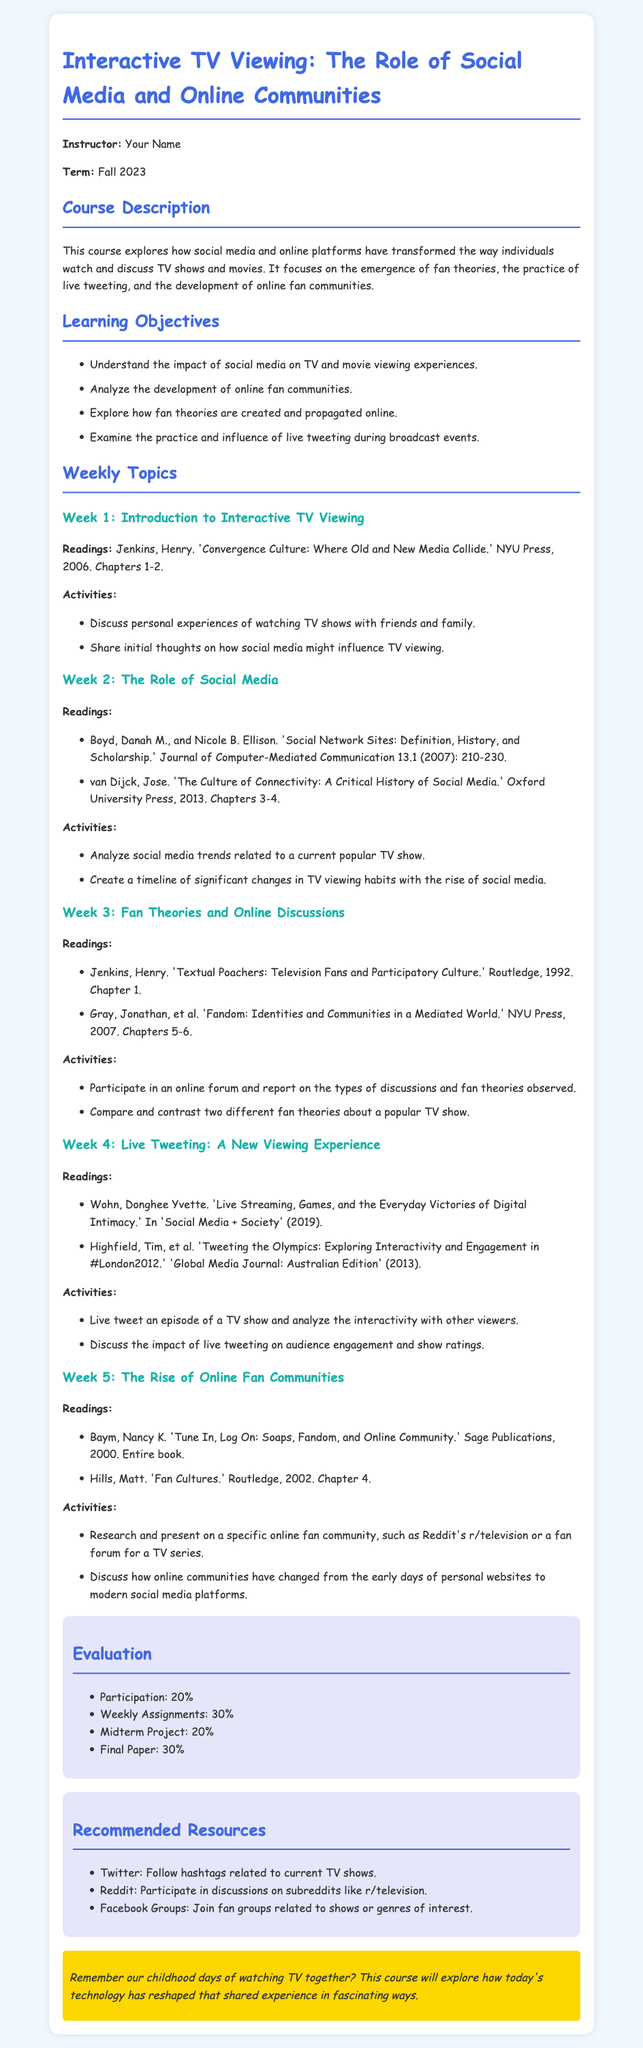What is the course title? The course title is stated at the beginning of the document.
Answer: Interactive TV Viewing: The Role of Social Media and Online Communities Who is the instructor? The instructor's name is listed in the introductory section of the document.
Answer: Your Name What percentage of the evaluation is based on participation? The evaluation section outlines the different components and their percentages.
Answer: 20% What is the reading for Week 1? Each weekly topic provides a list of readings, including the first week's.
Answer: Jenkins, Henry. 'Convergence Culture: Where Old and New Media Collide.' NYU Press, 2006. Chapters 1-2 What activity is suggested for Week 4? Each weekly topic includes specific suggested activities, including Week 4's.
Answer: Live tweet an episode of a TV show and analyze the interactivity with other viewers How many weeks does the syllabus cover? The weekly topics section lists the number of weeks covered in the course.
Answer: 5 weeks What type of resources are recommended? The recommended resources section outlines different kinds of online platforms for student engagement.
Answer: Twitter, Reddit, Facebook Groups What is the total percentage for the midterm project? The evaluation section provides the percentage breakdown for various components.
Answer: 20% 